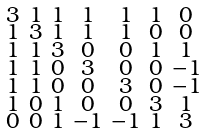Convert formula to latex. <formula><loc_0><loc_0><loc_500><loc_500>\begin{smallmatrix} 3 & 1 & 1 & 1 & 1 & 1 & 0 \\ 1 & 3 & 1 & 1 & 1 & 0 & 0 \\ 1 & 1 & 3 & 0 & 0 & 1 & 1 \\ 1 & 1 & 0 & 3 & 0 & 0 & - 1 \\ 1 & 1 & 0 & 0 & 3 & 0 & - 1 \\ 1 & 0 & 1 & 0 & 0 & 3 & 1 \\ 0 & 0 & 1 & - 1 & - 1 & 1 & 3 \end{smallmatrix}</formula> 